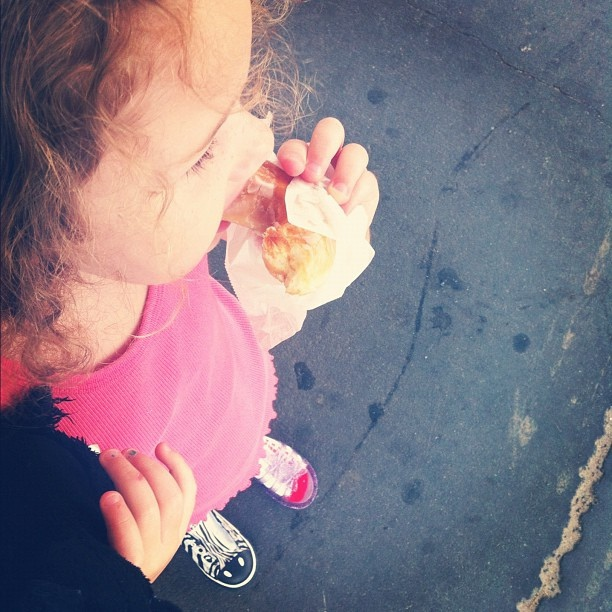Describe the objects in this image and their specific colors. I can see people in black, lightpink, tan, and ivory tones, teddy bear in black, navy, purple, and brown tones, and donut in black, beige, tan, and salmon tones in this image. 